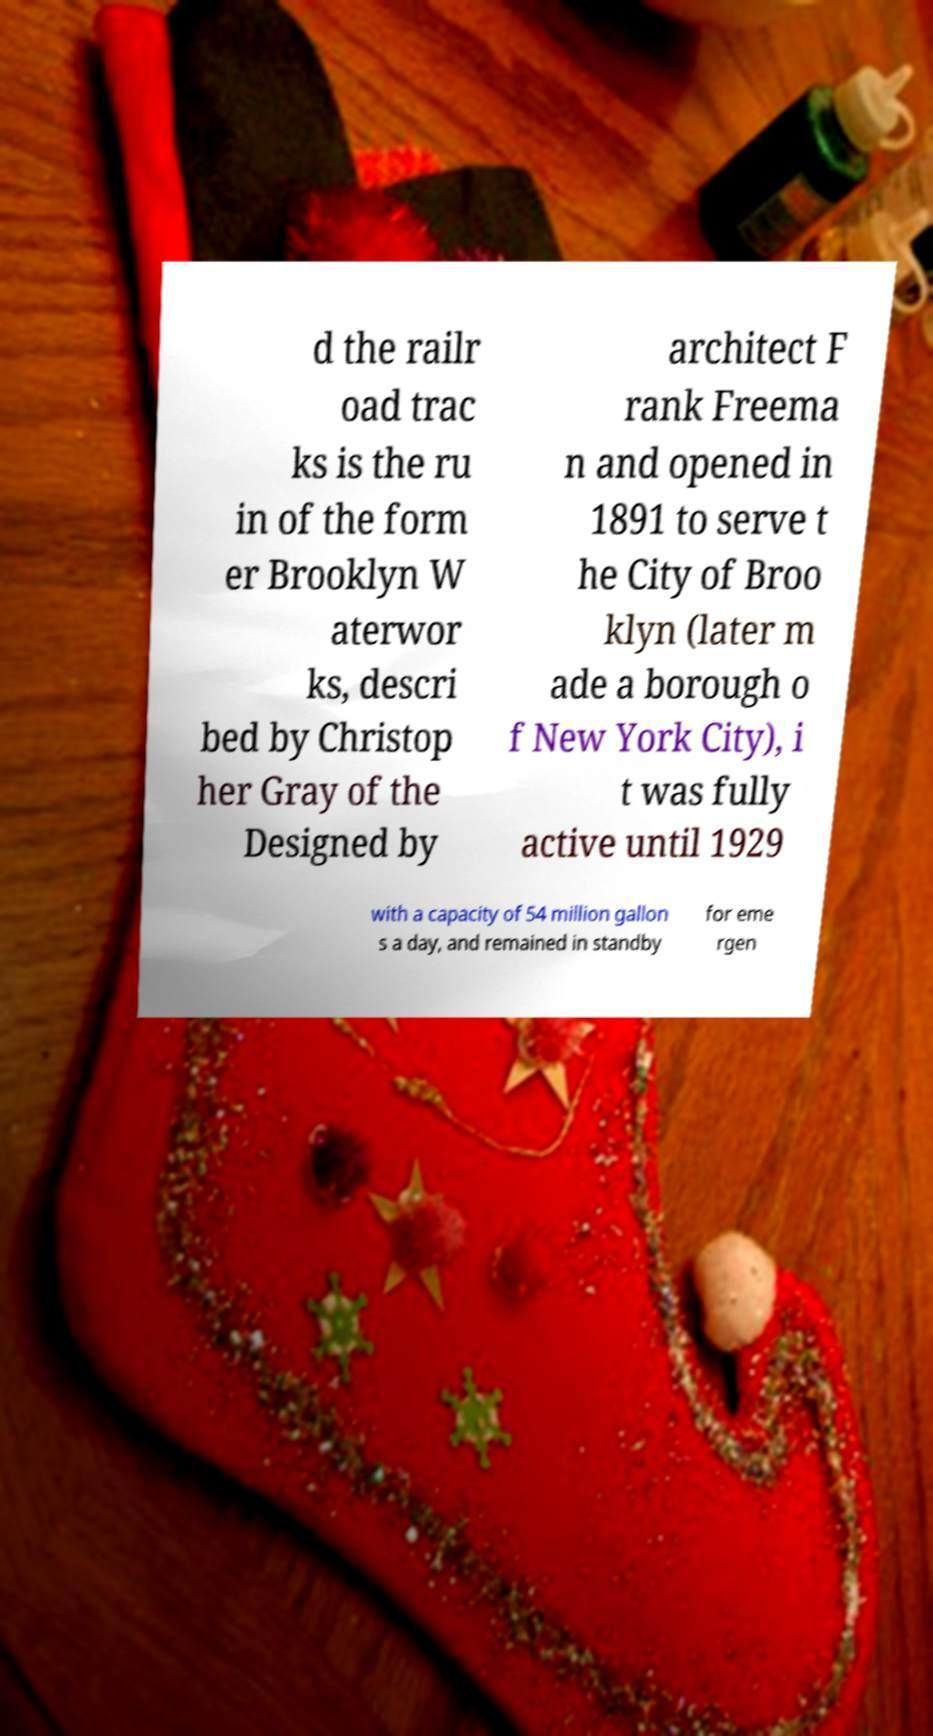I need the written content from this picture converted into text. Can you do that? d the railr oad trac ks is the ru in of the form er Brooklyn W aterwor ks, descri bed by Christop her Gray of the Designed by architect F rank Freema n and opened in 1891 to serve t he City of Broo klyn (later m ade a borough o f New York City), i t was fully active until 1929 with a capacity of 54 million gallon s a day, and remained in standby for eme rgen 